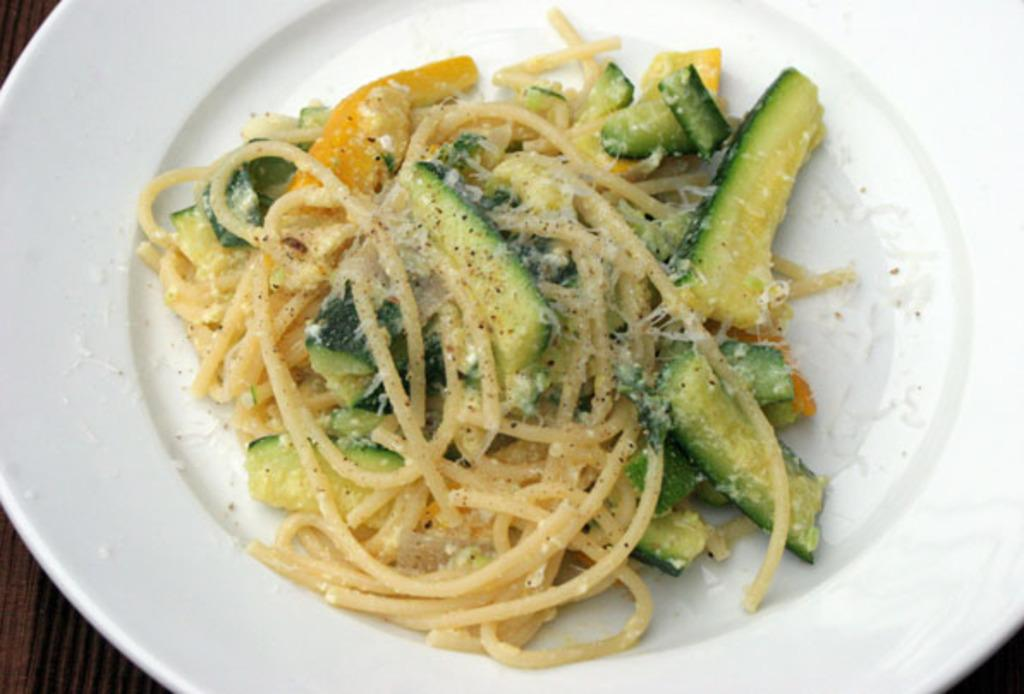What is the main object in the center of the image? There is a plate in the center of the image. What is on the plate? The plate contains noodles. Are there any other food items on the plate besides noodles? Yes, there are other food items on the plate. What type of egg is being cooked in the pan in the image? There is no pan or egg present in the image; it only features a plate with noodles and other food items. 